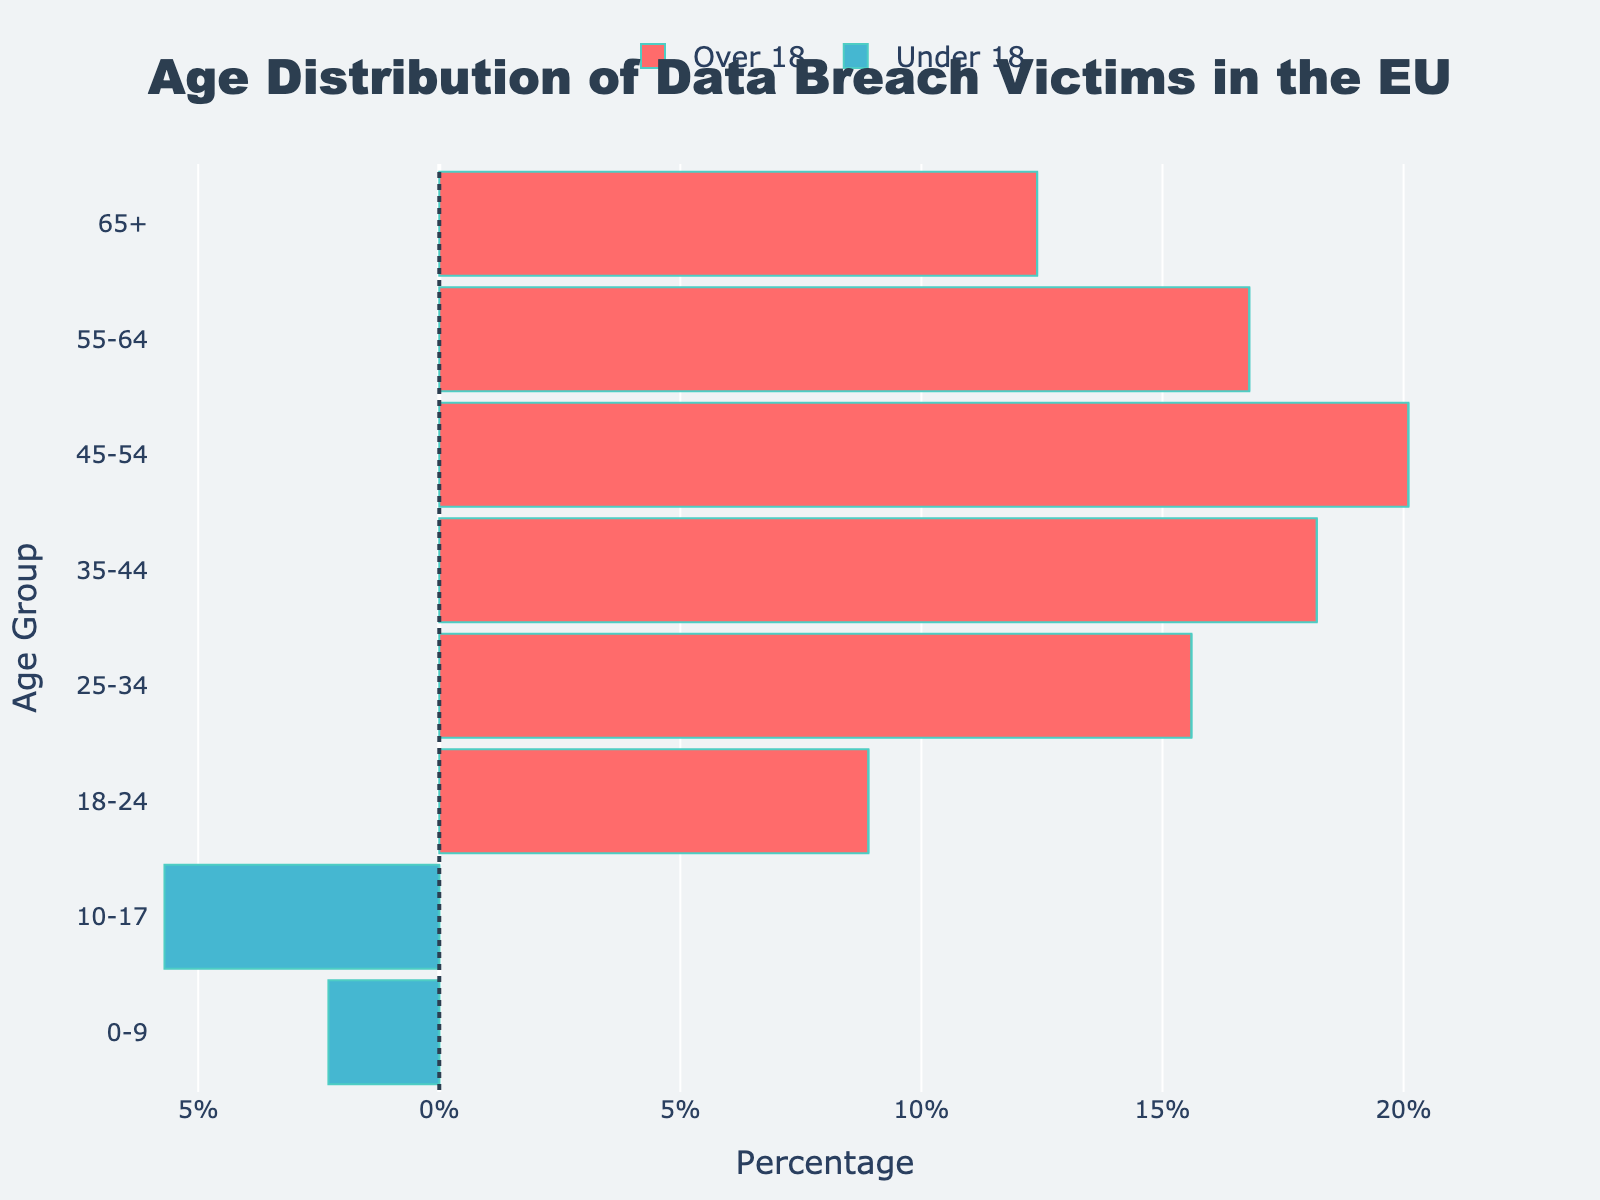What's the title of the figure? The title of the figure is centrally located at the top of the chart. It is large, bold, and clearly states the subject of the figure.
Answer: Age Distribution of Data Breach Victims in the EU What percentage of data breach victims are under 18 in the 0-9 age group? The 0-9 age group is represented by the leftmost bar for under 18, which extends to 2.3% on the negative x-axis.
Answer: 2.3% How does the percentage of data breach victims in the 35-44 age group compare between the under 18 and over 18 categories? For the 35-44 age group, the bar for over 18 extends to 18.2% on the positive x-axis, while there is no bar for under 18, indicating 0% for that category.
Answer: Over 18 is 18.2%, Under 18 is 0% What is the total percentage of data breach victims aged under 18 in all the age groups combined? Summing the percentages for the under 18 categories: 2.3% (0-9) + 5.7% (10-17) = 8.0%
Answer: 8.0% Which age group has the highest percentage of over 18 data breach victims? By observing the longest bar for over 18 on the positive x-axis, the 45-54 age group has the longest bar extending to 20.1%.
Answer: 45-54 age group with 20.1% What is the difference in the percentage of data breach victims between the 18-24 and 65+ age groups for over 18? Subtract the percentage for the 65+ age group (12.4%) from the 18-24 age group (8.9%): 12.4% - 8.9% = 3.5%
Answer: 3.5% What is the percentage of data breach victims over 60 years old compared to those under 18 years old? The percentage for over 60 years is represented by the 65+ age group (12.4%), and for under 18, the combined total is 2.3% (0-9) + 5.7% (10-17) = 8.0%. Compare 12.4% and 8.0%.
Answer: 12.4% for 65+, 8.0% for under 18 Identify the age group with the smallest percentage of victims in the over 18 category and provide its value. By looking at the shortest bar on the positive x-axis for over 18, the 18-24 age group has the smallest percentage, extending to 8.9%.
Answer: 18-24 age group with 8.9% How many age groups have 0% data breach victims in the under 18 category? By counting the bars on the negative x-axis which extend to 0% in the under 18 category, the age groups are 18-24, 25-34, 35-44, 45-54, 55-64, and 65+, which results in 6 groups.
Answer: 6 What is the overall trend in the percentage of data breach victims as the age increases for the over 18 category? Observing the positive x-axis bars, the trend shows an increase in the percentage of victims until the 45-54 age group (20.1%) and then a gradual decline towards the 65+ age group (12.4%).
Answer: Increase until 45-54, then decrease 